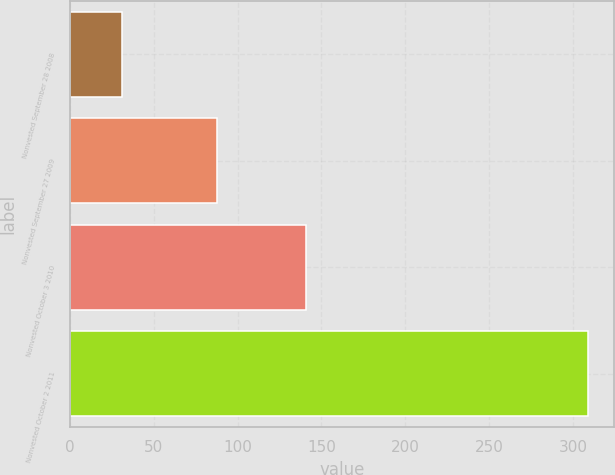<chart> <loc_0><loc_0><loc_500><loc_500><bar_chart><fcel>Nonvested September 28 2008<fcel>Nonvested September 27 2009<fcel>Nonvested October 3 2010<fcel>Nonvested October 2 2011<nl><fcel>31<fcel>88<fcel>141<fcel>309<nl></chart> 